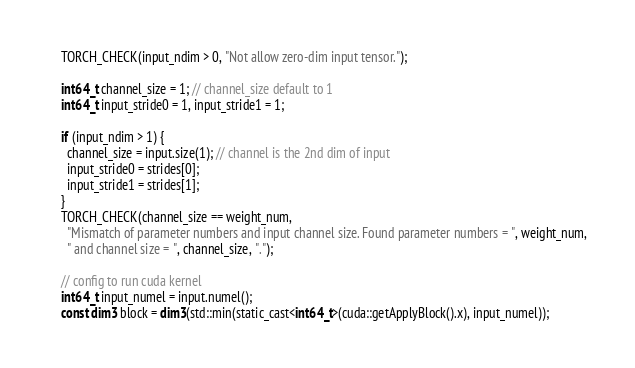<code> <loc_0><loc_0><loc_500><loc_500><_Cuda_>    TORCH_CHECK(input_ndim > 0, "Not allow zero-dim input tensor.");

    int64_t channel_size = 1; // channel_size default to 1
    int64_t input_stride0 = 1, input_stride1 = 1;

    if (input_ndim > 1) {
      channel_size = input.size(1); // channel is the 2nd dim of input
      input_stride0 = strides[0];
      input_stride1 = strides[1];
    }
    TORCH_CHECK(channel_size == weight_num,
      "Mismatch of parameter numbers and input channel size. Found parameter numbers = ", weight_num,
      " and channel size = ", channel_size, ".");

    // config to run cuda kernel
    int64_t input_numel = input.numel();
    const dim3 block = dim3(std::min(static_cast<int64_t>(cuda::getApplyBlock().x), input_numel));</code> 